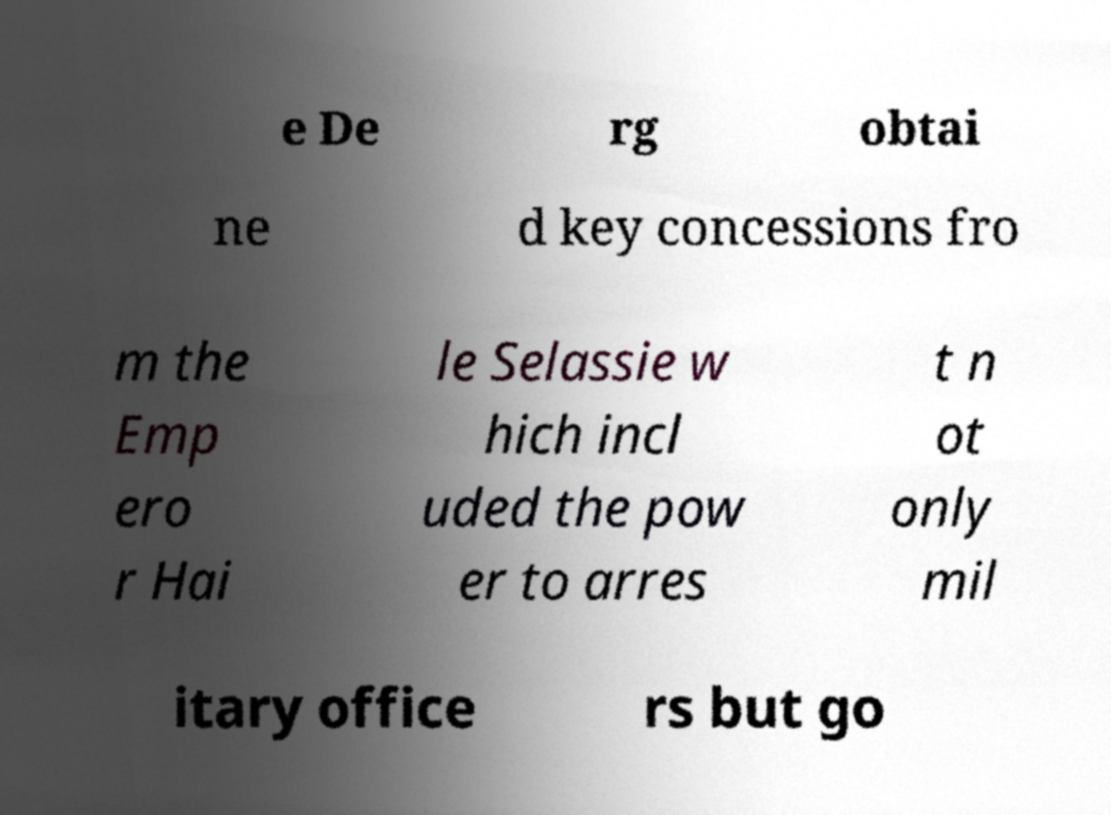Please read and relay the text visible in this image. What does it say? e De rg obtai ne d key concessions fro m the Emp ero r Hai le Selassie w hich incl uded the pow er to arres t n ot only mil itary office rs but go 